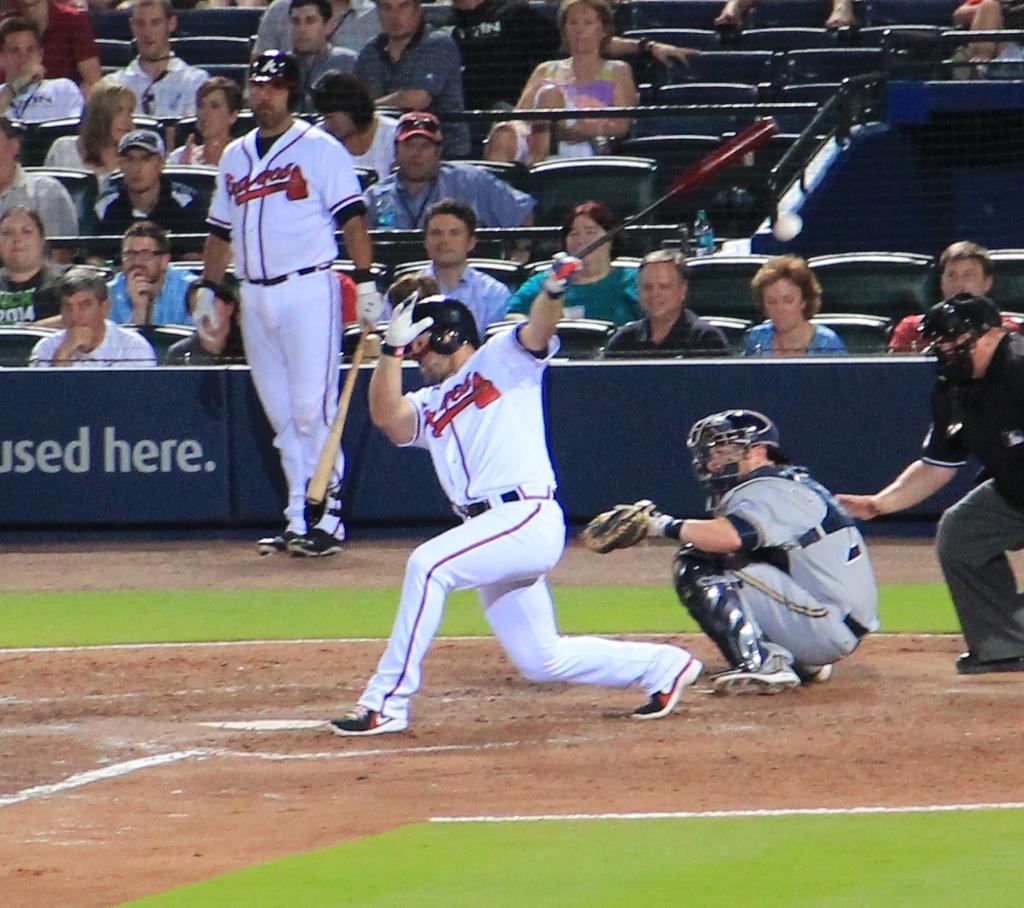What team do the players in white play for?
Provide a succinct answer. Braves. 